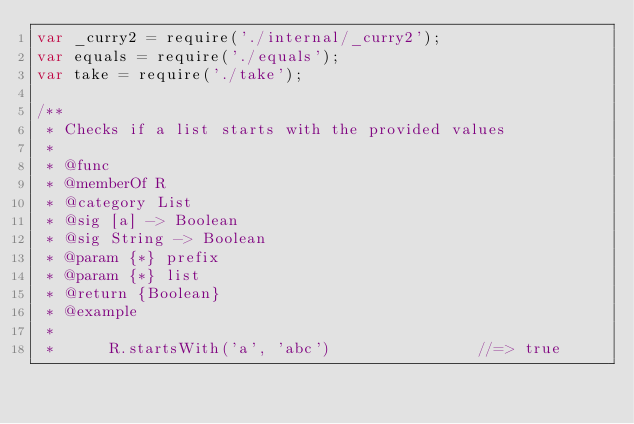<code> <loc_0><loc_0><loc_500><loc_500><_JavaScript_>var _curry2 = require('./internal/_curry2');
var equals = require('./equals');
var take = require('./take');

/**
 * Checks if a list starts with the provided values
 *
 * @func
 * @memberOf R
 * @category List
 * @sig [a] -> Boolean
 * @sig String -> Boolean
 * @param {*} prefix
 * @param {*} list
 * @return {Boolean}
 * @example
 *
 *      R.startsWith('a', 'abc')                //=> true</code> 